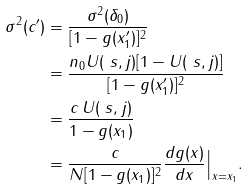Convert formula to latex. <formula><loc_0><loc_0><loc_500><loc_500>\sigma ^ { 2 } ( c ^ { \prime } ) & = \frac { \sigma ^ { 2 } ( \delta _ { 0 } ) } { [ 1 - g ( x ^ { \prime } _ { 1 } ) ] ^ { 2 } } \\ & = \frac { n _ { 0 } U ( \ s , j ) [ 1 - U ( \ s , j ) ] } { [ 1 - g ( x ^ { \prime } _ { 1 } ) ] ^ { 2 } } \\ & = \frac { c \, U ( \ s , j ) } { 1 - g ( x _ { 1 } ) } \\ & = \frac { c } { N [ 1 - g ( x _ { 1 } ) ] ^ { 2 } } \frac { d g ( x ) } { d x } \Big | _ { x = x _ { 1 } } .</formula> 